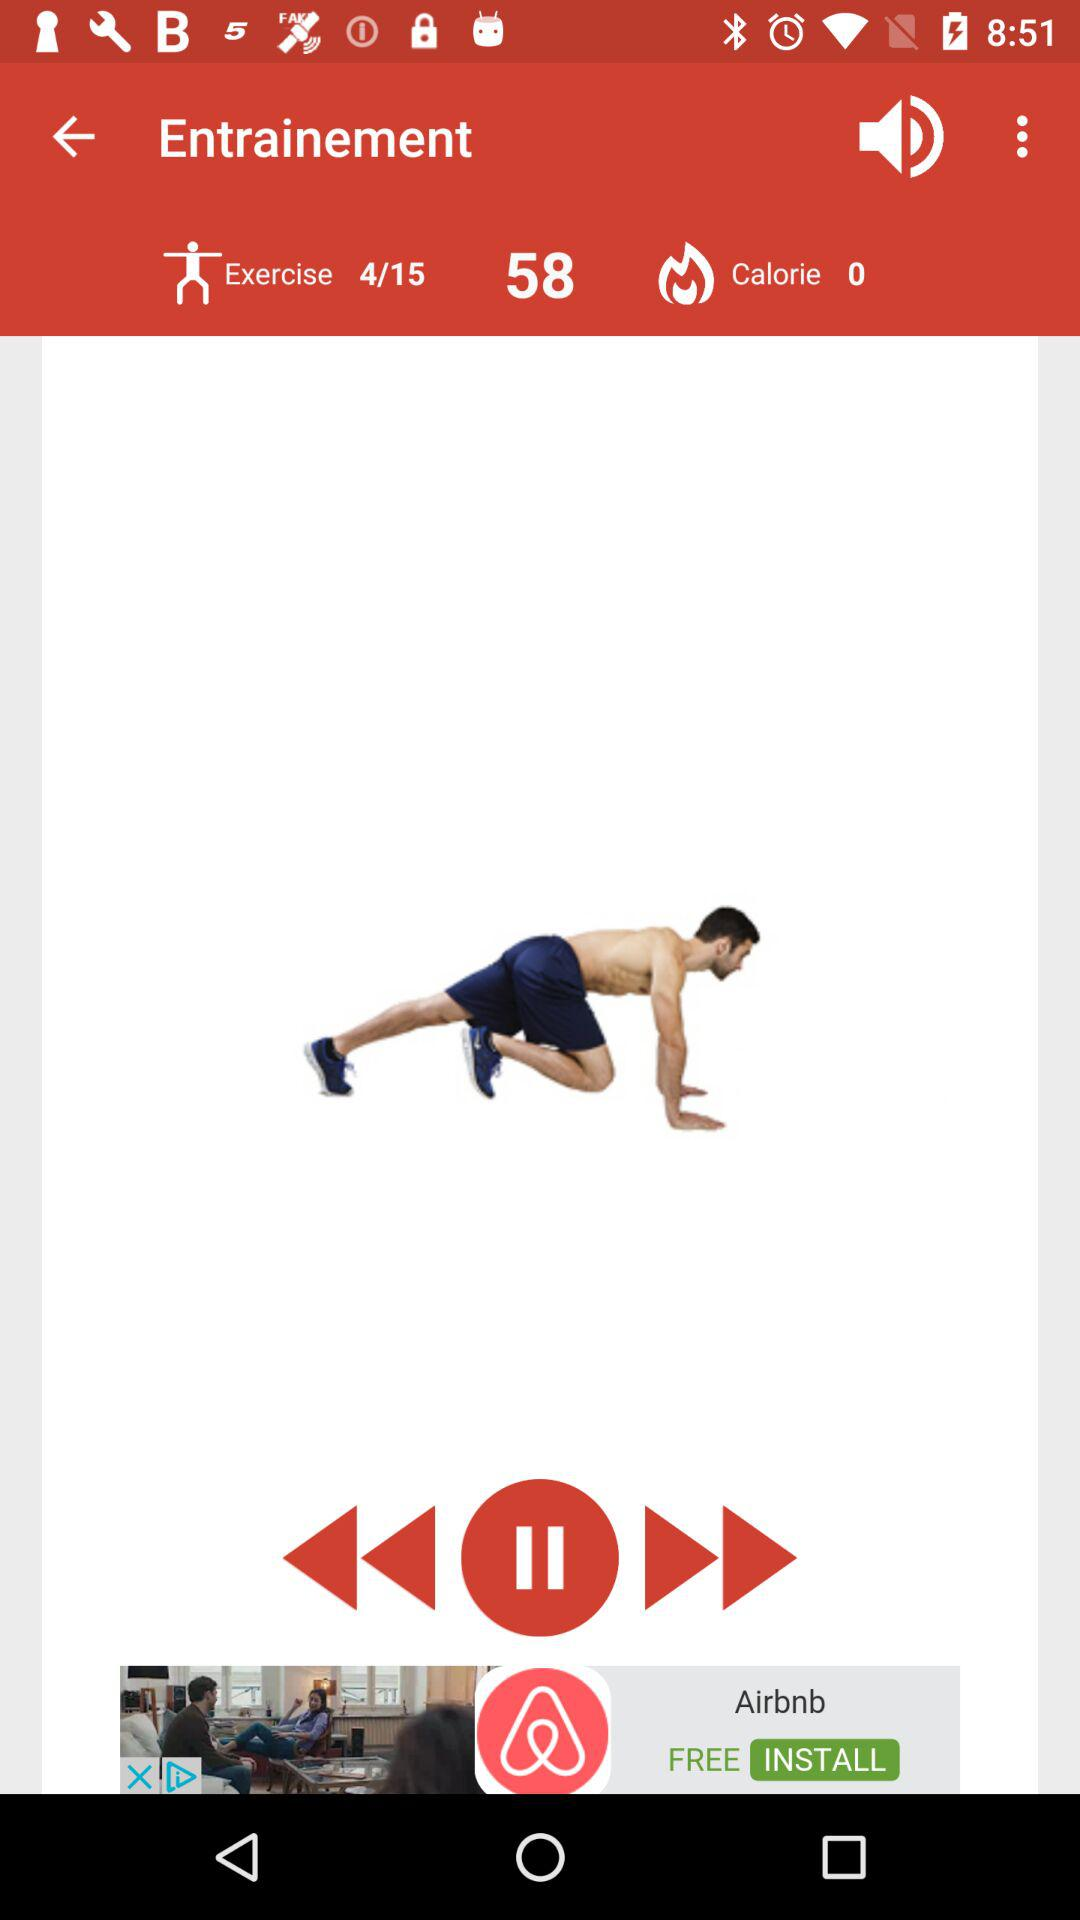How many calories have been burned?
Answer the question using a single word or phrase. 0 